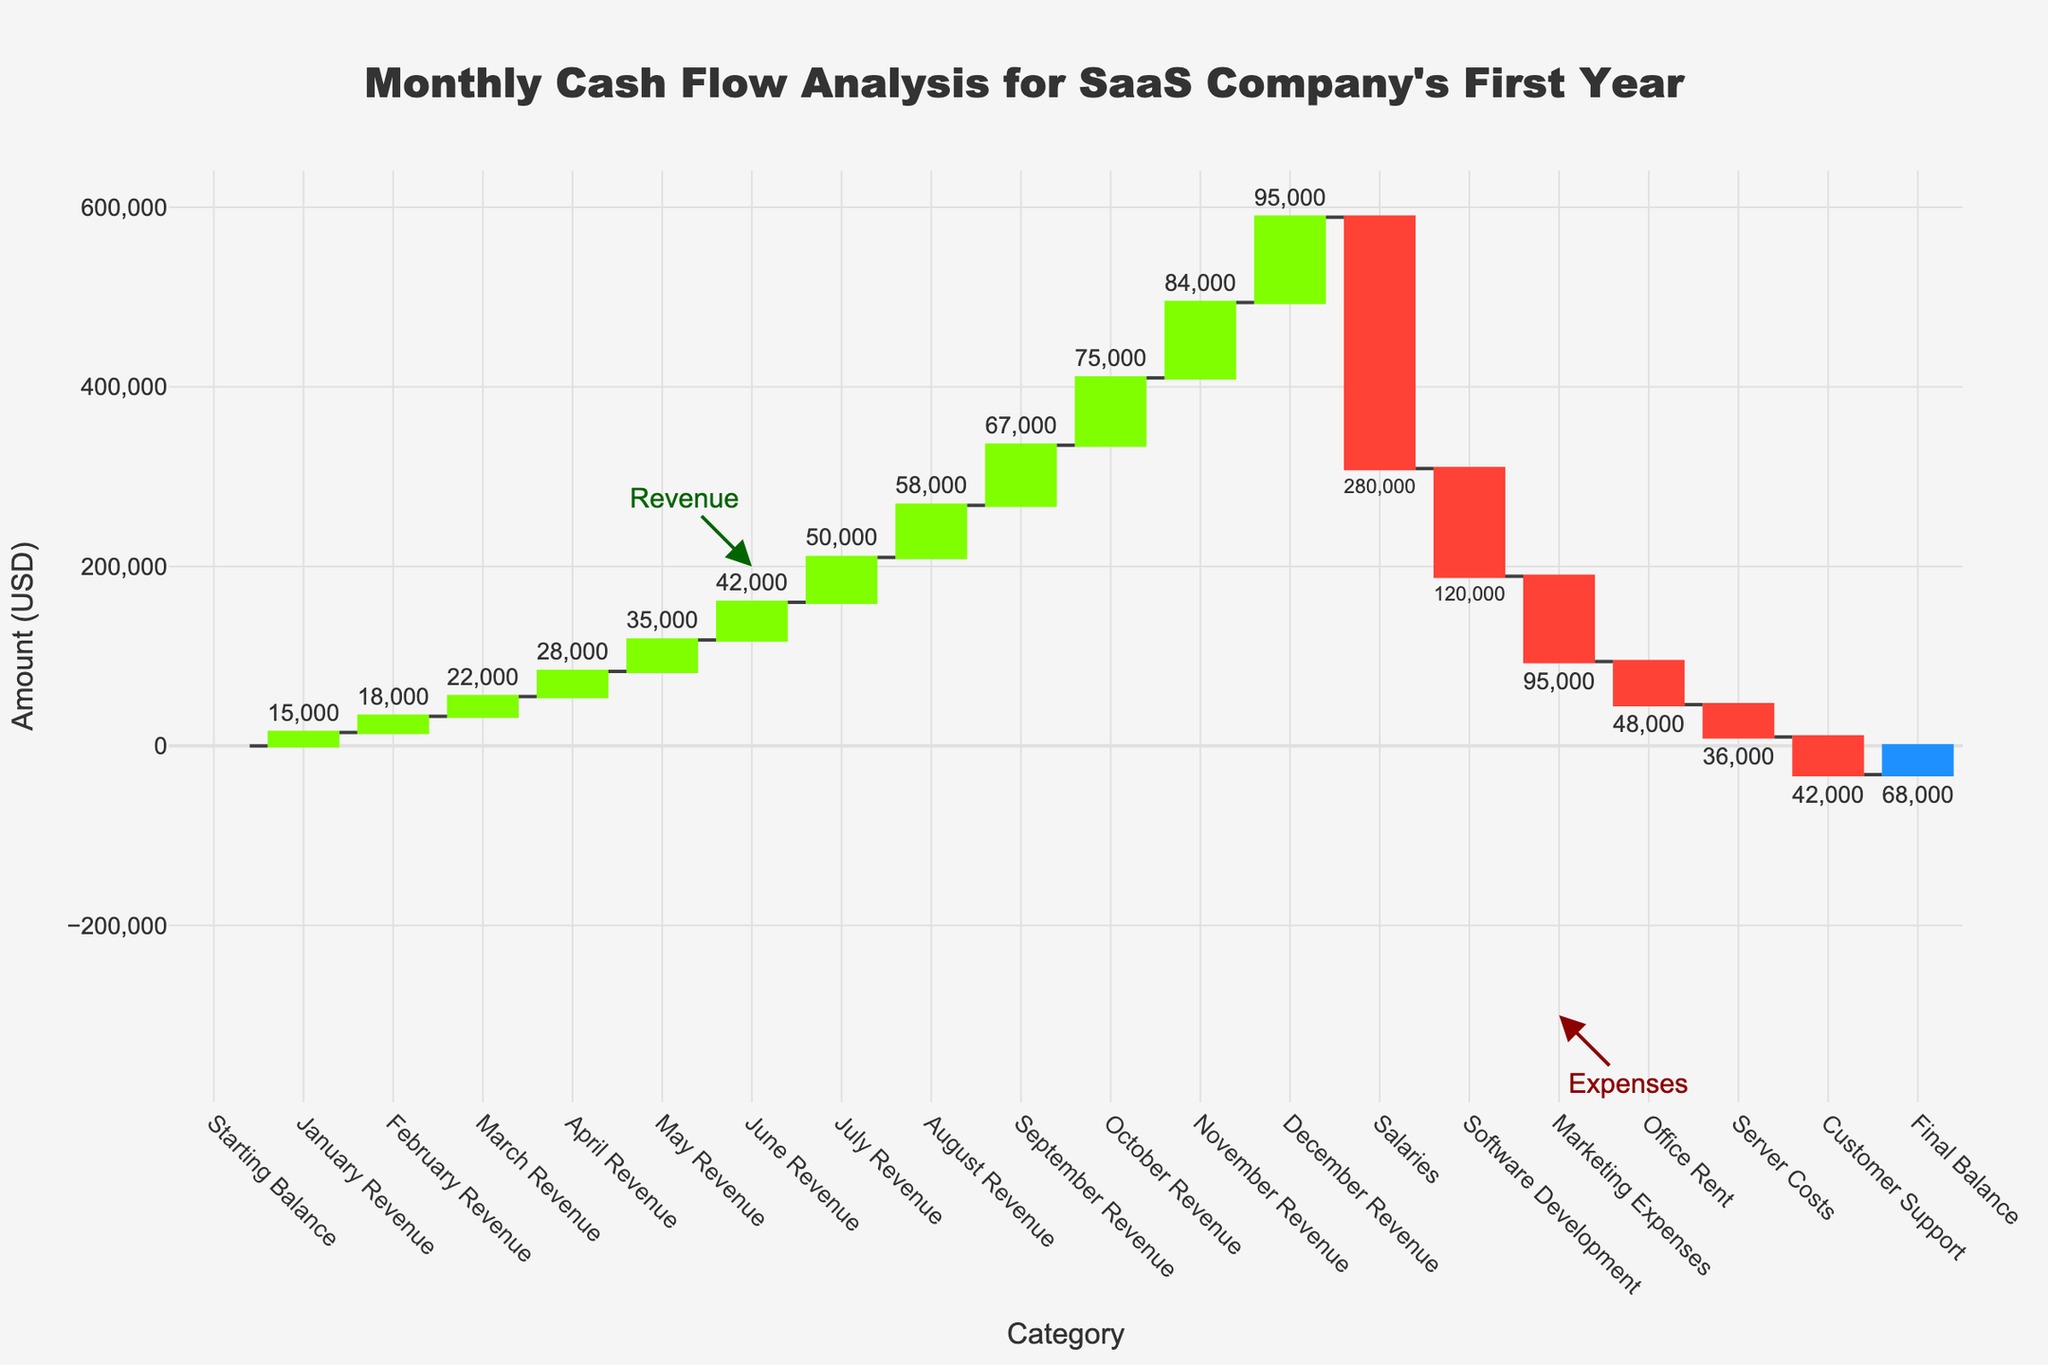What is the title of the chart? The title of the chart is located at the top and centered, reading "Monthly Cash Flow Analysis for SaaS Company's First Year"
Answer: Monthly Cash Flow Analysis for SaaS Company's First Year What is the final balance at the end of the year? The final balance is depicted as the last bar in the waterfall chart; the annotation shows the amount is 68,000
Answer: 68,000 How much revenue did the company generate in March? Locate the bar labeled "March Revenue" and refer to the annotation, which indicates the amount is 22,000
Answer: 22,000 Which expense category has the highest cost? Compare the heights of the red decreasing bars. The highest bar represents "Salaries" with a cost of -280,000
Answer: Salaries What is the total amount of expenses? To find the total expenses, sum the negative values: -280,000 (Salaries) + -120,000 (Software Development) + -95,000 (Marketing Expenses) + -48,000 (Office Rent) + -36,000 (Server Costs) + -42,000 (Customer Support) = -621,000
Answer: -621,000 How does the revenue in July compare to the revenue in December? Contrast the heights and annotations of the bars for "July Revenue" (50,000) and "December Revenue" (95,000). December revenue is higher
Answer: December revenue is higher What is the total revenue generated from August to December? Add the revenue amounts from August (58,000), September (67,000), October (75,000), November (84,000), and December (95,000). Total = 58,000 + 67,000 + 75,000 + 84,000 + 95,000 = 379,000
Answer: 379,000 What is the combined expense of Marketing Expenses and Office Rent? Add the amounts for "Marketing Expenses" (-95,000) and "Office Rent" (-48,000). Combined expense = -95,000 + -48,000 = -143,000
Answer: -143,000 Which month had the lowest revenue increase compared to the previous month, and what was the amount? Calculate the difference between consecutive months' revenues and identify the smallest increase. February (18,000) – January (15,000) = 3,000, the lowest increase
Answer: February, 3,000 What categories contribute to the increasing and decreasing values in the chart? The increasing values (shown in green) are the monthly revenues, and the decreasing values (shown in red) are the various expenses like Salaries, Software Development, Marketing Expenses, Office Rent, Server Costs, and Customer Support
Answer: Revenues and Expenses 